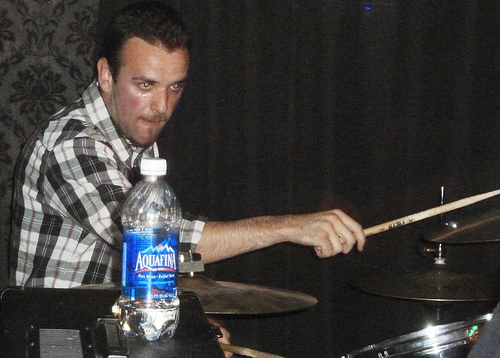<image>
Can you confirm if the water bottle is behind the cymbal? No. The water bottle is not behind the cymbal. From this viewpoint, the water bottle appears to be positioned elsewhere in the scene. Is there a water in front of the drum stick? Yes. The water is positioned in front of the drum stick, appearing closer to the camera viewpoint. 